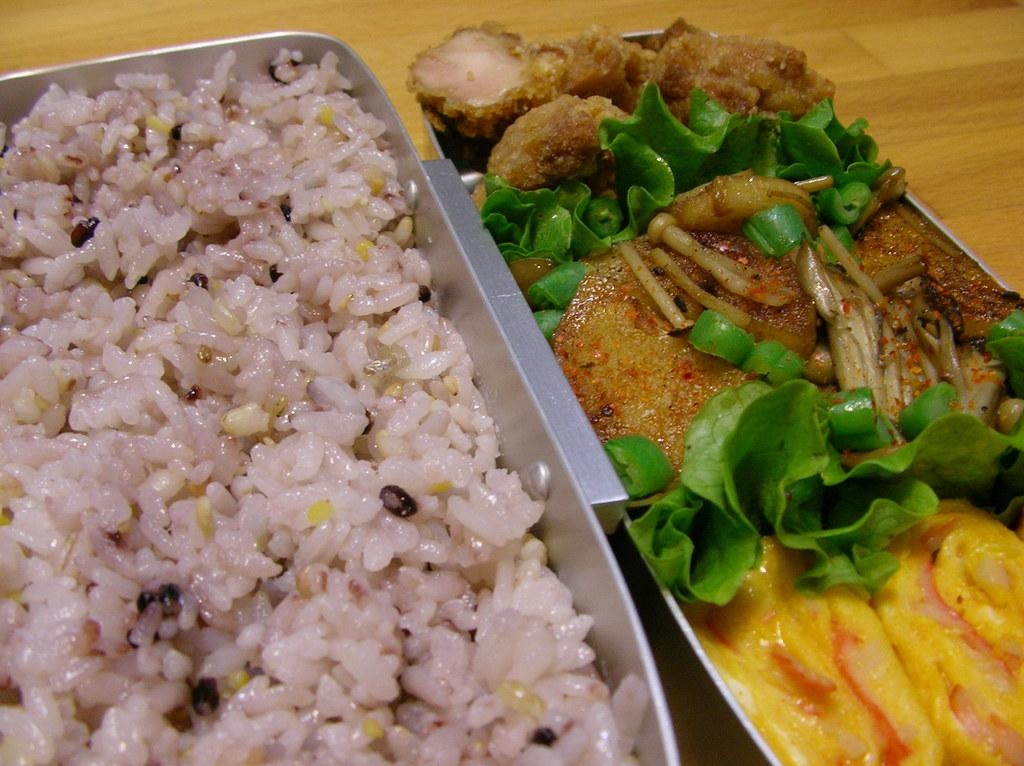What is the main object in the image? There is a wooden plank in the image. What is placed on the wooden plank? There are two trays on the wooden plank. What is in the first tray? The first tray contains boiled rice. What is in the second tray? The second tray contains curry with vegetable garnish. Can you see any dinosaurs walking on the wooden plank in the image? No, there are no dinosaurs present in the image. 